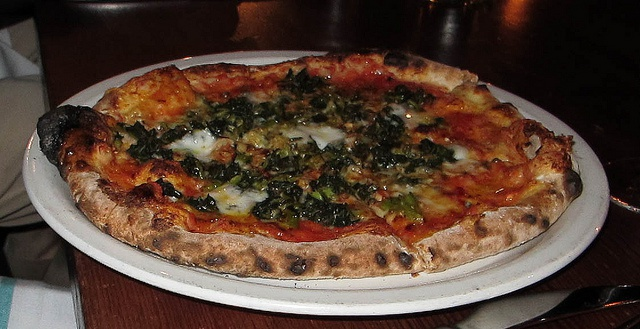Describe the objects in this image and their specific colors. I can see pizza in black, maroon, and brown tones, dining table in black, maroon, gray, and darkgray tones, and knife in black and gray tones in this image. 